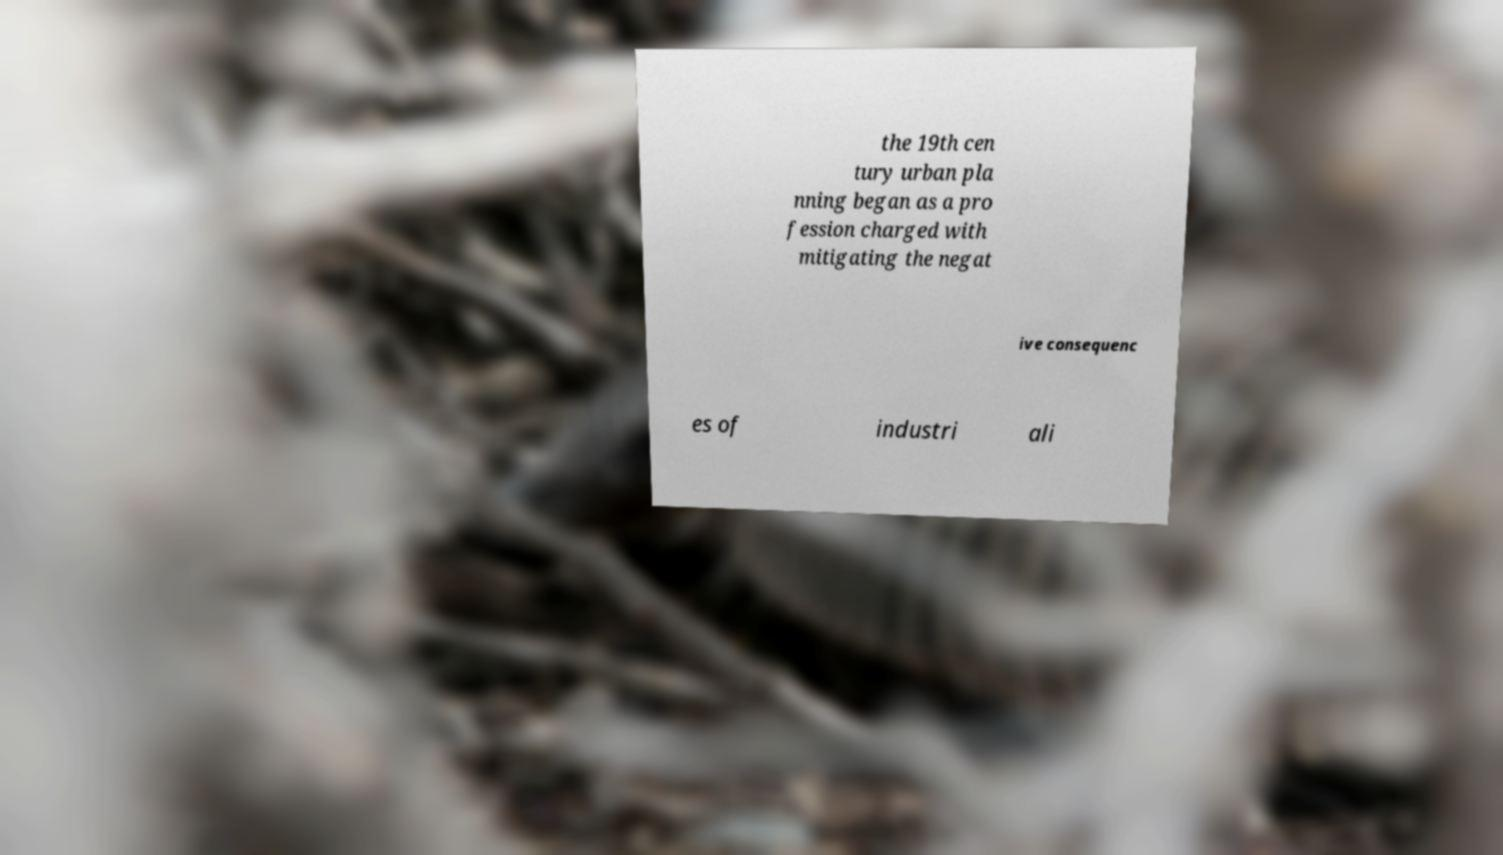There's text embedded in this image that I need extracted. Can you transcribe it verbatim? the 19th cen tury urban pla nning began as a pro fession charged with mitigating the negat ive consequenc es of industri ali 